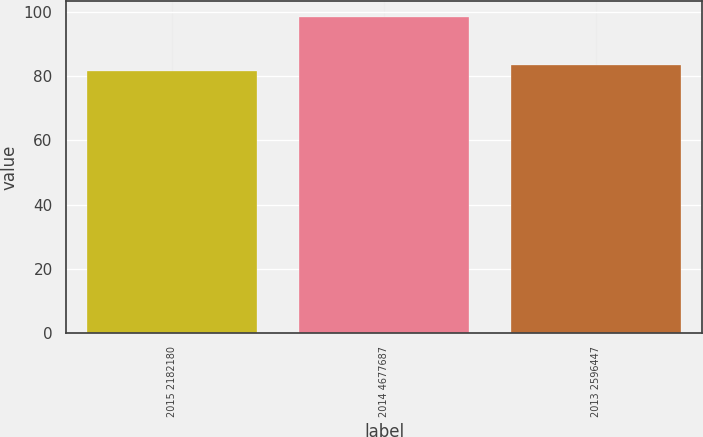<chart> <loc_0><loc_0><loc_500><loc_500><bar_chart><fcel>2015 2182180<fcel>2014 4677687<fcel>2013 2596447<nl><fcel>81.57<fcel>98.38<fcel>83.25<nl></chart> 